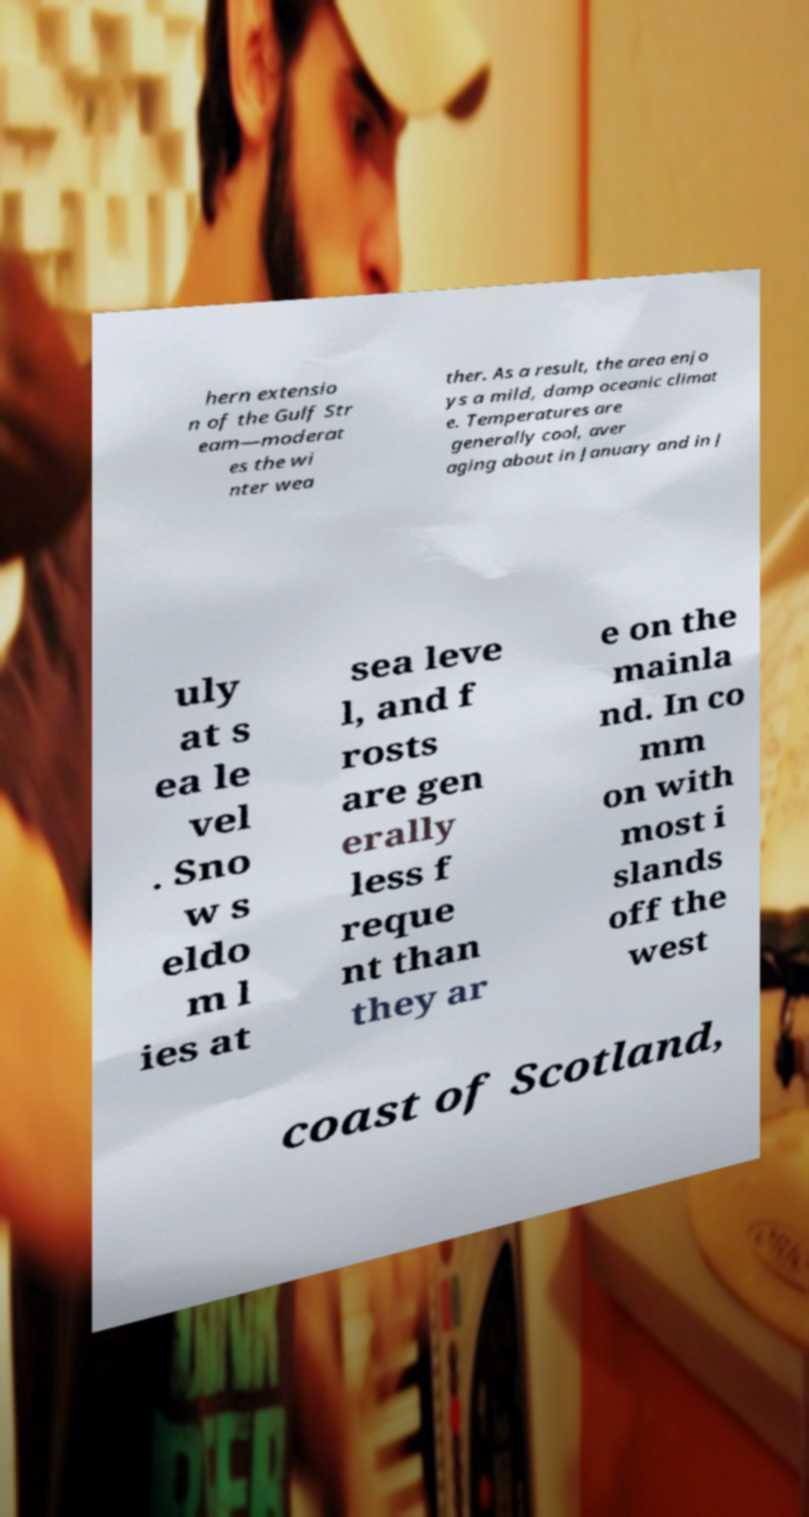Can you read and provide the text displayed in the image?This photo seems to have some interesting text. Can you extract and type it out for me? hern extensio n of the Gulf Str eam—moderat es the wi nter wea ther. As a result, the area enjo ys a mild, damp oceanic climat e. Temperatures are generally cool, aver aging about in January and in J uly at s ea le vel . Sno w s eldo m l ies at sea leve l, and f rosts are gen erally less f reque nt than they ar e on the mainla nd. In co mm on with most i slands off the west coast of Scotland, 